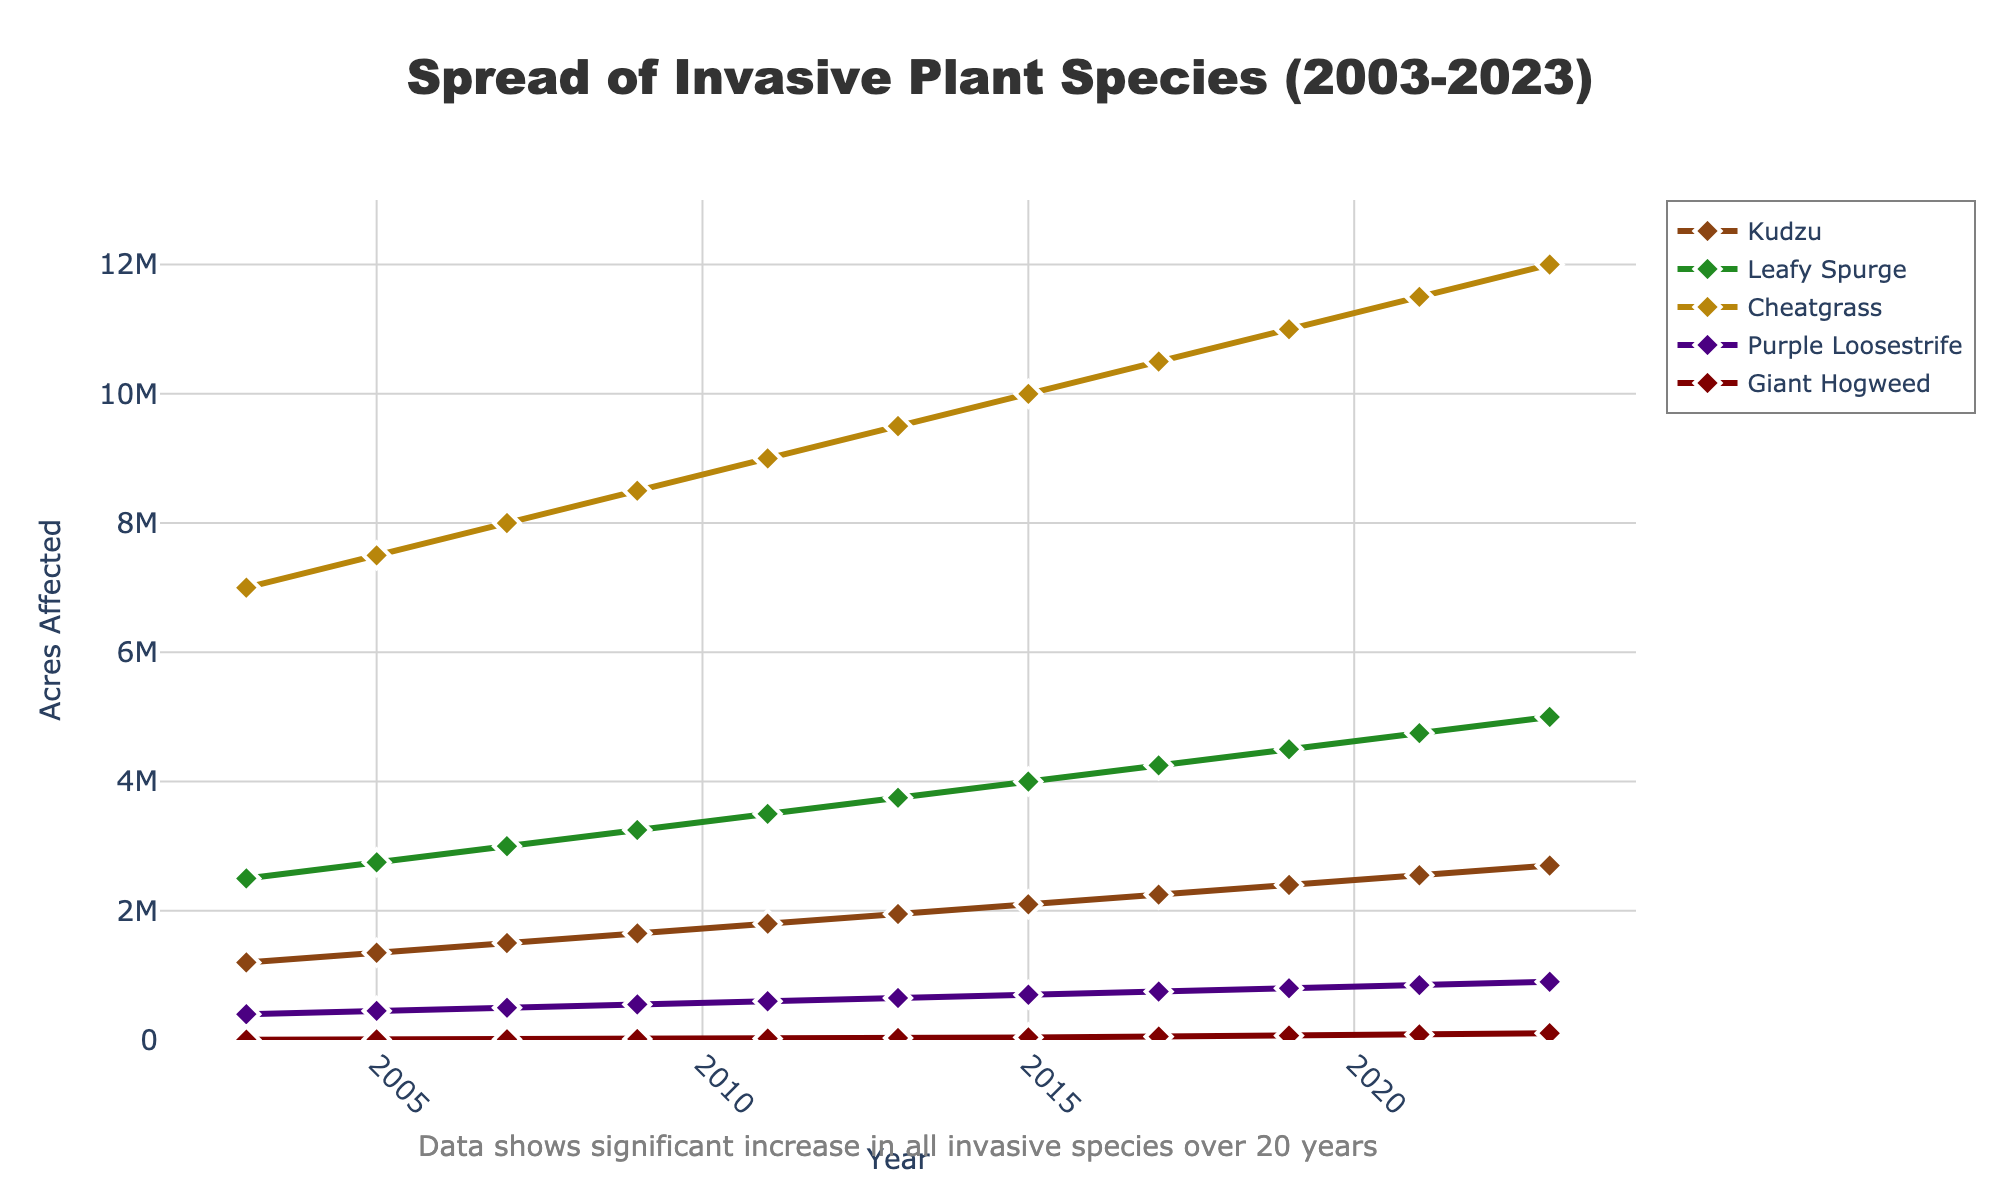What is the total increase in acres affected by Kudzu from 2003 to 2023? To find the total increase, subtract the acres affected in 2003 from the acres affected in 2023. So, it would be 2,700,000 acres in 2023 minus 1,200,000 acres in 2003, which equals 1,500,000 acres.
Answer: 1,500,000 acres Which plant species showed the greatest growth in acres affected between any two consecutive data points? To identify the greatest growth between any two consecutive data points, observe the largest vertical jump between two consecutive years for each species and compare them. For Cheatgrass, the increase from 2003 to 2005 is 500,000 acres. This is the largest single consecutive growth among all species in the dataset.
Answer: Cheatgrass How many acres did Giant Hogweed increase from 2011 to 2023? To find the increase, subtract the 2011 value from the 2023 value. For Giant Hogweed, it would be 105,000 acres minus 22,500 acres, which equals 82,500 acres.
Answer: 82,500 acres Compare the spread of Leafy Spurge and Kudzu in 2023. Which one affected more acres, and by how much? First, find the 2023 value for both species. Leafy Spurge affected 5,000,000 acres, and Kudzu affected 2,700,000 acres. Subtract the acres affected by Kudzu from those affected by Leafy Spurge: 5,000,000 - 2,700,000 = 2,300,000 acres. Leafy Spurge affected more acres by 2,300,000 acres.
Answer: Leafy Spurge by 2,300,000 acres In what year did Purple Loosestrife affect as many acres as Giant Hogweed did in 2019? Check the acres affected by Giant Hogweed in 2019, which is 67,500 acres. Then, look through the years for Purple Loosestrife and find the closest match. In 2009, Purple Loosestrife affected 550,000 acres. No similar value was achieved throughout this period for Purple Loosestrife compared to Giant Hogweed in 2019.
Answer: Not applicable Which species saw a steady increase in acres affected every recorded year? To identify a steady increase, observe if the acres affected consistently increase in each recorded year for a species without any decrease. All species, namely Kudzu, Leafy Spurge, Cheatgrass, Purple Loosestrife, and Giant Hogweed, have shown a steady increase every recorded year.
Answer: All species Calculate the average acres affected by Cheatgrass over the 20 years period. To calculate the average, sum the acres affected by Cheatgrass from 2003 to 2023 and divide by the number of years. The total sum is (7,000,000 + 7,500,000 + 8,000,000 + 8,500,000 + 9,000,000 + 9,500,000 + 10,000,000 + 10,500,000 + 11,000,000 + 11,500,000 + 12,000,000) = 104,500,000 acres. The number of years is 11, so the average is 104,500,000 / 11 ≈ 9,500,000 acres.
Answer: 9,500,000 acres 